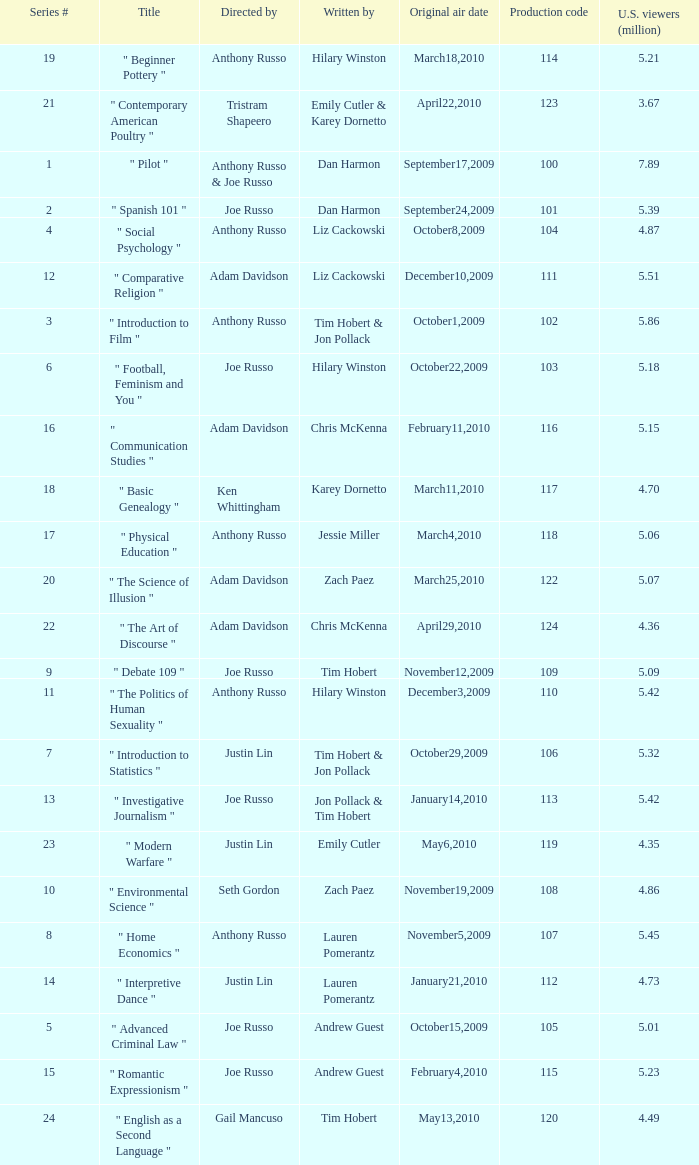What is the title of the series # 8? " Home Economics ". 